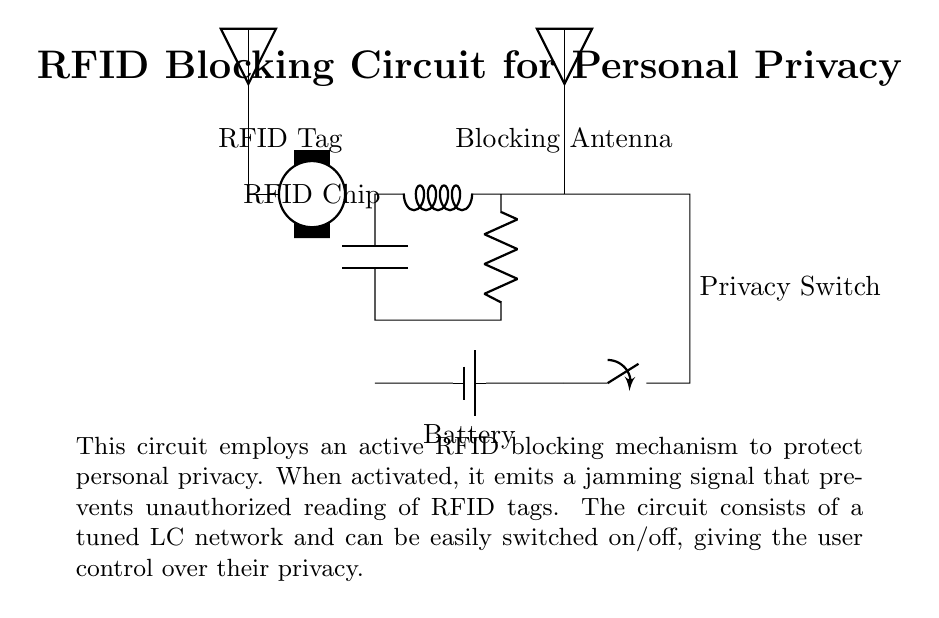What component is used to provide power to the circuit? The circuit uses a battery as the source of power, which is indicated at the bottom connected to the circuit.
Answer: battery What does the switch control in this circuit? The switch controls the connection to the blocking antenna, allowing the user to activate or deactivate the RFID jamming signal.
Answer: blocking antenna What type of signal does the blocking antenna emit? The blocking antenna emits a jamming signal to prevent unauthorized reading of RFID tags when activated.
Answer: jamming signal What is the main function of the RFID blocking circuit? The main function is to protect personal privacy by preventing unauthorized RFID tag reading through an active jamming mechanism.
Answer: privacy protection How is the circuit's blocking feature activated? The blocking feature is activated by closing the switch, which connects power to the blocking antenna and allows it to emit the jamming signal.
Answer: closing the switch What components are present in the blocking circuit? The blocking circuit consists of an inductor, a capacitor, and a resistor connected in a tuned LC network.
Answer: inductor, capacitor, resistor 